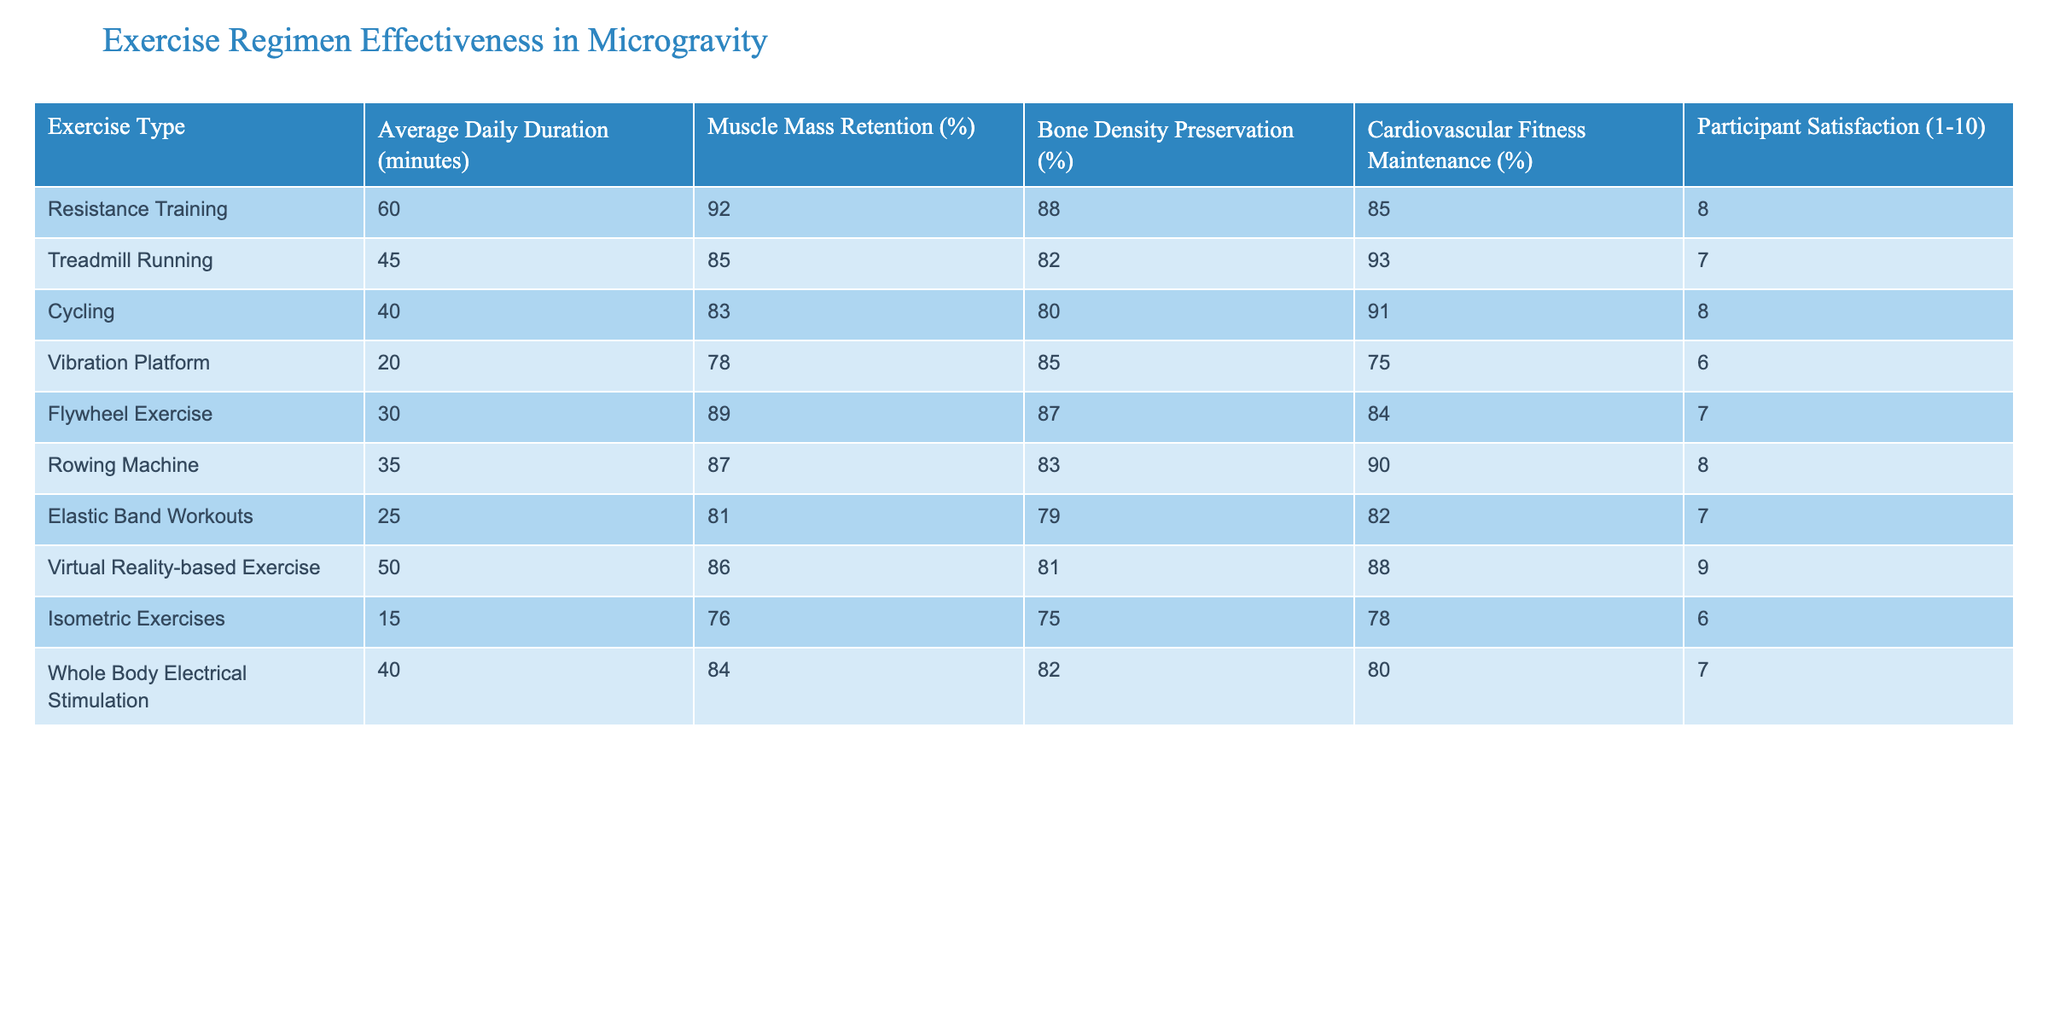What is the muscle mass retention percentage for Resistance Training? The table displays the muscle mass retention percentage for Resistance Training as 92%.
Answer: 92% Which exercise type has the highest cardiovascular fitness maintenance percentage? By looking at the cardiovascular fitness maintenance percentages, Treadmill Running has the highest percentage at 93%.
Answer: 93% Calculate the average muscle mass retention percentage of all exercise types. The muscle mass retention percentages are 92, 85, 83, 78, 89, 87, 81, 86, 76, and 84. Summing these gives 92 + 85 + 83 + 78 + 89 + 87 + 81 + 86 + 76 + 84 =  850. There are 10 types of exercises, so the average is 850 / 10 = 85%.
Answer: 85% Is the participant satisfaction rating for Vibration Platform greater than 7? The participant satisfaction rating for Vibration Platform is 6, which is less than 7, so the answer is no.
Answer: No What is the difference in muscle mass retention percentage between Flywheel Exercise and Cycling? Flywheel Exercise has a muscle mass retention of 89%, while Cycling has 83%. The difference calculated is 89 - 83 = 6%.
Answer: 6% What exercise type has the highest average in both muscle mass retention and participant satisfaction? Resistance Training has the highest muscle mass retention at 92% and a participant satisfaction rating of 8. No other exercise type exceeds these values in both categories, confirming that it is the highest for both.
Answer: Resistance Training What is the overall trend in muscle mass retention as the average daily duration of exercise decreases? Looking at the data, as the average daily duration of exercise decreases, muscle mass retention percentage tends to decrease as well. For instance, Resistance Training (60 minutes) has 92%, while Vibration Platform (20 minutes) has 78%. This indicates a negative trend overall.
Answer: Negative trend Which exercise type has the lowest bone density preservation percentage? The exercise type with the lowest bone density preservation percentage is Isometric Exercises, which shows a percentage of 75%.
Answer: 75% What is the average participant satisfaction rating for exercises with at least 40 minutes of duration? The relevant exercises (Treadmill Running, Cycling, Flywheel Exercise, Rowing Machine, Whole Body Electrical Stimulation) have satisfaction ratings of 7, 8, 7, 8, and 7 respectively. The total is 7 + 8 + 7 + 8 + 7 = 37. Dividing by 5 yields an average of 37 / 5 = 7.4.
Answer: 7.4 